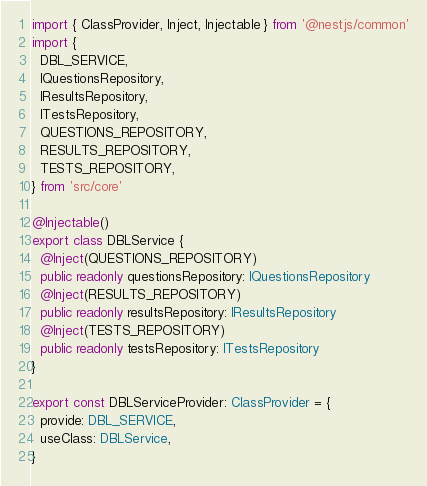Convert code to text. <code><loc_0><loc_0><loc_500><loc_500><_TypeScript_>import { ClassProvider, Inject, Injectable } from '@nestjs/common'
import {
  DBL_SERVICE,
  IQuestionsRepository,
  IResultsRepository,
  ITestsRepository,
  QUESTIONS_REPOSITORY,
  RESULTS_REPOSITORY,
  TESTS_REPOSITORY,
} from 'src/core'

@Injectable()
export class DBLService {
  @Inject(QUESTIONS_REPOSITORY)
  public readonly questionsRepository: IQuestionsRepository
  @Inject(RESULTS_REPOSITORY)
  public readonly resultsRepository: IResultsRepository
  @Inject(TESTS_REPOSITORY)
  public readonly testsRepository: ITestsRepository
}

export const DBLServiceProvider: ClassProvider = {
  provide: DBL_SERVICE,
  useClass: DBLService,
}
</code> 